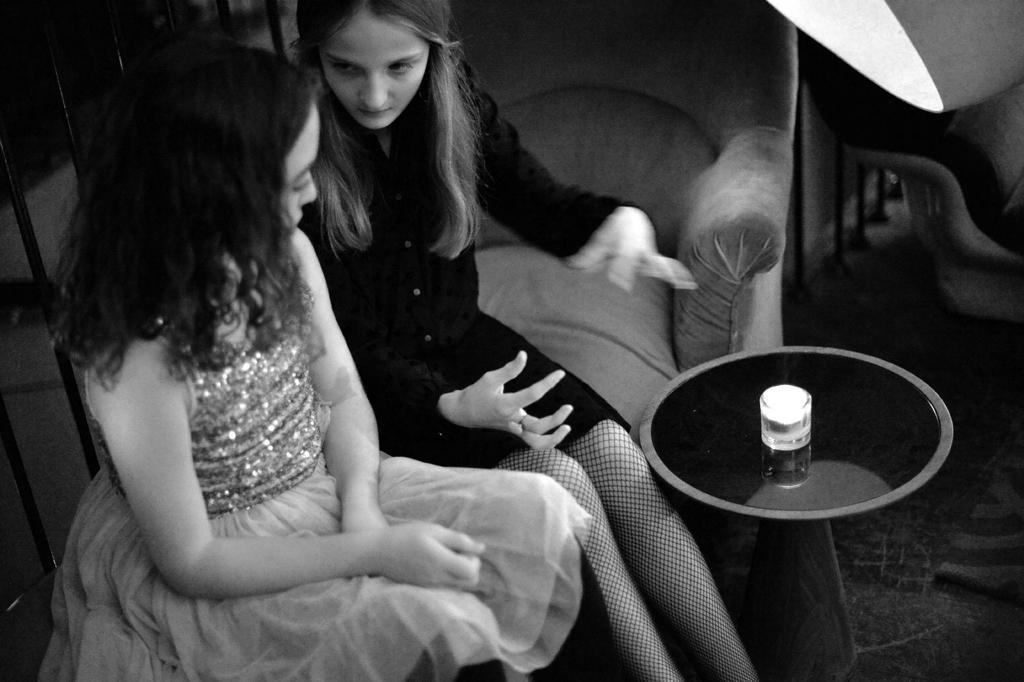In one or two sentences, can you explain what this image depicts? in the image we can see two women were sitting on the couch. In front we can see table and coming to background we can see chair and light. 